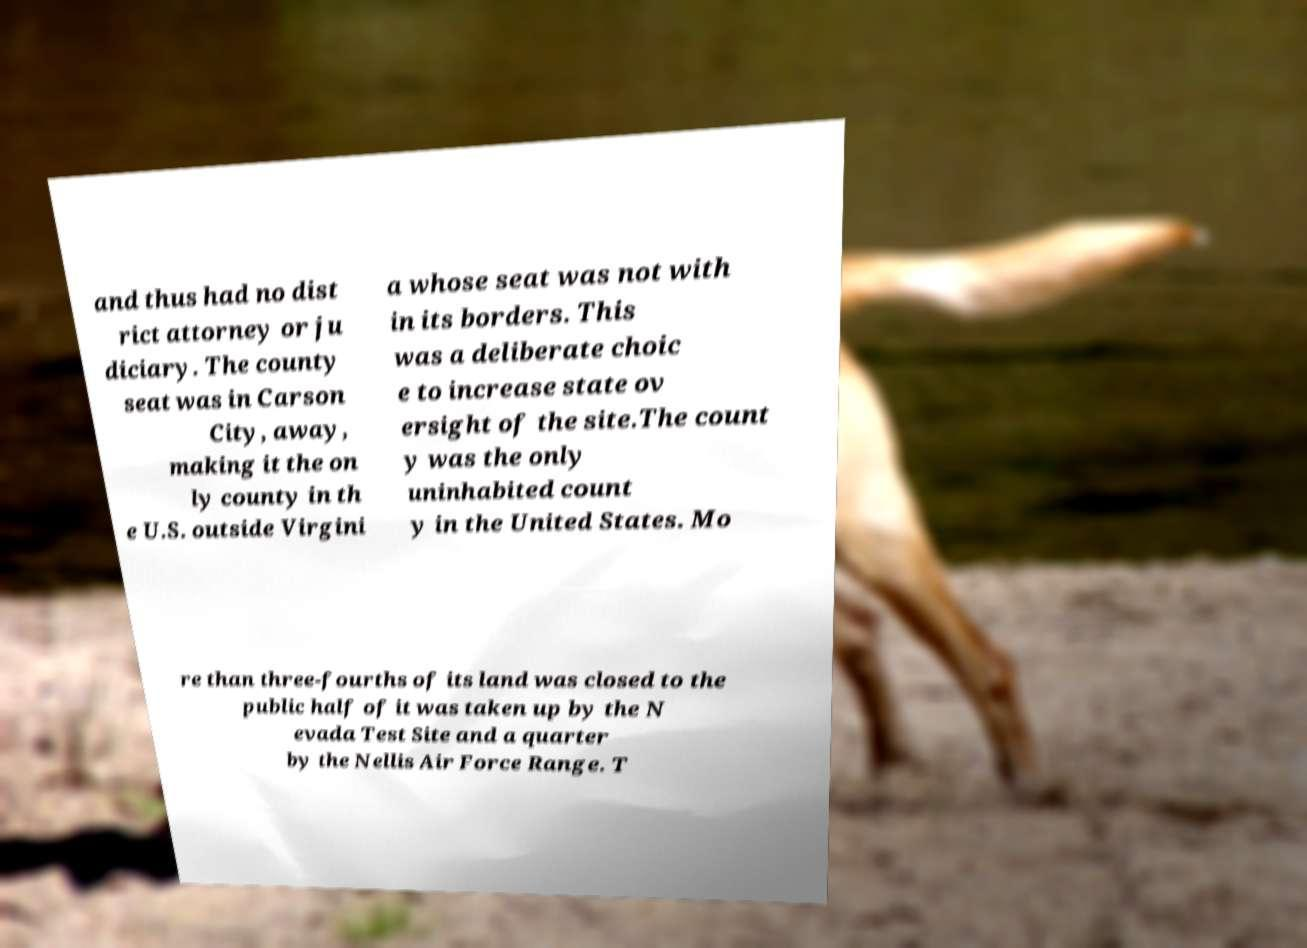Can you read and provide the text displayed in the image?This photo seems to have some interesting text. Can you extract and type it out for me? and thus had no dist rict attorney or ju diciary. The county seat was in Carson City, away, making it the on ly county in th e U.S. outside Virgini a whose seat was not with in its borders. This was a deliberate choic e to increase state ov ersight of the site.The count y was the only uninhabited count y in the United States. Mo re than three-fourths of its land was closed to the public half of it was taken up by the N evada Test Site and a quarter by the Nellis Air Force Range. T 